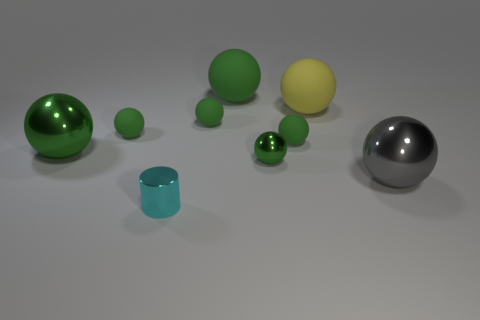The metal object that is the same color as the small metallic sphere is what shape?
Provide a succinct answer. Sphere. There is a matte sphere behind the large yellow matte thing; does it have the same color as the tiny rubber thing left of the small cyan metallic cylinder?
Offer a terse response. Yes. How many things are tiny shiny things that are in front of the gray shiny object or small red spheres?
Your response must be concise. 1. How many other things are there of the same shape as the small cyan thing?
Offer a terse response. 0. What number of green objects are big spheres or small metal spheres?
Your answer should be compact. 3. What color is the other big sphere that is made of the same material as the yellow sphere?
Your response must be concise. Green. Is the green thing on the right side of the tiny green metal sphere made of the same material as the big thing behind the yellow matte sphere?
Your response must be concise. Yes. There is a shiny object that is the same color as the tiny metal sphere; what is its size?
Provide a succinct answer. Large. There is a green thing in front of the big green metal thing; what is it made of?
Provide a short and direct response. Metal. There is a small metallic object behind the gray thing; is it the same shape as the big yellow object left of the gray sphere?
Make the answer very short. Yes. 